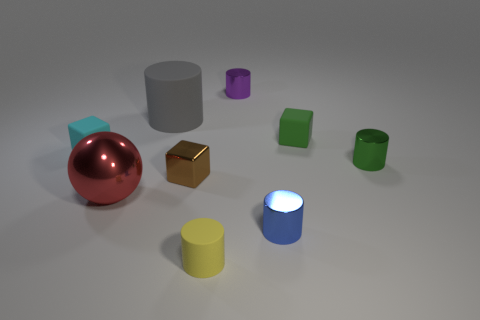There is a tiny rubber cube left of the small block in front of the green metallic object; what number of green objects are in front of it? The green metallic object has one green object positioned directly in front of it. It appears to be a small green block with a comparable texture and finish, suggesting it is perhaps part of a set with the larger green object. 